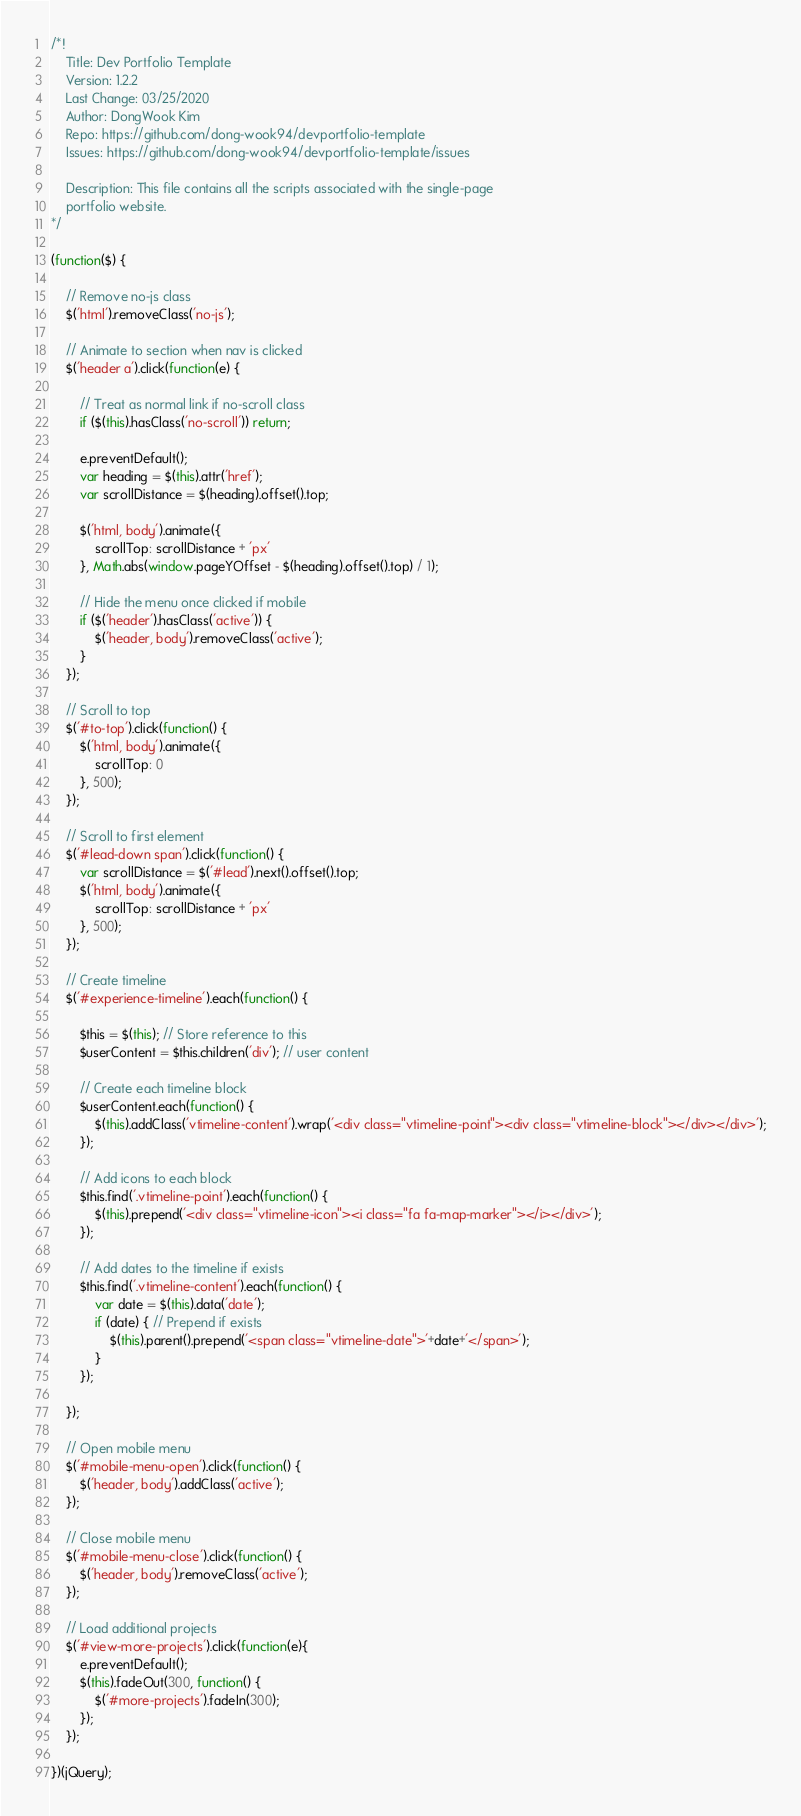Convert code to text. <code><loc_0><loc_0><loc_500><loc_500><_JavaScript_>/*!
    Title: Dev Portfolio Template
    Version: 1.2.2
    Last Change: 03/25/2020
    Author: DongWook Kim
    Repo: https://github.com/dong-wook94/devportfolio-template
    Issues: https://github.com/dong-wook94/devportfolio-template/issues

    Description: This file contains all the scripts associated with the single-page
    portfolio website.
*/

(function($) {

    // Remove no-js class
    $('html').removeClass('no-js');

    // Animate to section when nav is clicked
    $('header a').click(function(e) {

        // Treat as normal link if no-scroll class
        if ($(this).hasClass('no-scroll')) return;

        e.preventDefault();
        var heading = $(this).attr('href');
        var scrollDistance = $(heading).offset().top;

        $('html, body').animate({
            scrollTop: scrollDistance + 'px'
        }, Math.abs(window.pageYOffset - $(heading).offset().top) / 1);

        // Hide the menu once clicked if mobile
        if ($('header').hasClass('active')) {
            $('header, body').removeClass('active');
        }
    });

    // Scroll to top
    $('#to-top').click(function() {
        $('html, body').animate({
            scrollTop: 0
        }, 500);
    });

    // Scroll to first element
    $('#lead-down span').click(function() {
        var scrollDistance = $('#lead').next().offset().top;
        $('html, body').animate({
            scrollTop: scrollDistance + 'px'
        }, 500);
    });

    // Create timeline
    $('#experience-timeline').each(function() {

        $this = $(this); // Store reference to this
        $userContent = $this.children('div'); // user content

        // Create each timeline block
        $userContent.each(function() {
            $(this).addClass('vtimeline-content').wrap('<div class="vtimeline-point"><div class="vtimeline-block"></div></div>');
        });

        // Add icons to each block
        $this.find('.vtimeline-point').each(function() {
            $(this).prepend('<div class="vtimeline-icon"><i class="fa fa-map-marker"></i></div>');
        });

        // Add dates to the timeline if exists
        $this.find('.vtimeline-content').each(function() {
            var date = $(this).data('date');
            if (date) { // Prepend if exists
                $(this).parent().prepend('<span class="vtimeline-date">'+date+'</span>');
            }
        });

    });

    // Open mobile menu
    $('#mobile-menu-open').click(function() {
        $('header, body').addClass('active');
    });

    // Close mobile menu
    $('#mobile-menu-close').click(function() {
        $('header, body').removeClass('active');
    });

    // Load additional projects
    $('#view-more-projects').click(function(e){
        e.preventDefault();
        $(this).fadeOut(300, function() {
            $('#more-projects').fadeIn(300);
        });
    });

})(jQuery);
</code> 